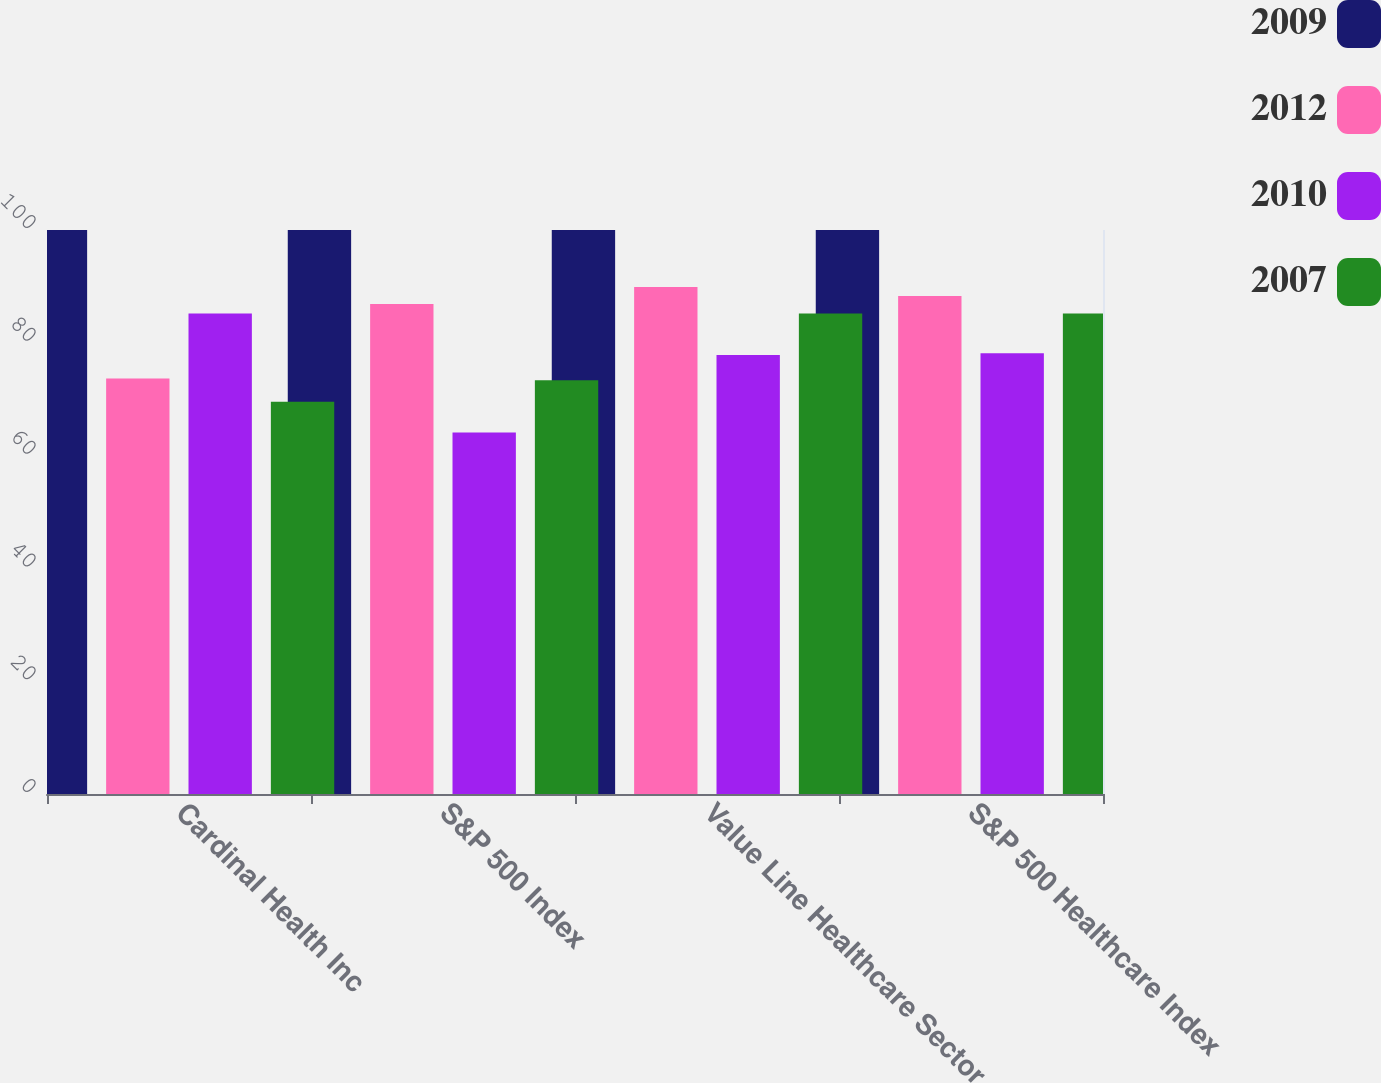Convert chart to OTSL. <chart><loc_0><loc_0><loc_500><loc_500><stacked_bar_chart><ecel><fcel>Cardinal Health Inc<fcel>S&P 500 Index<fcel>Value Line Healthcare Sector<fcel>S&P 500 Healthcare Index<nl><fcel>2009<fcel>100<fcel>100<fcel>100<fcel>100<nl><fcel>2012<fcel>73.68<fcel>86.88<fcel>89.88<fcel>88.28<nl><fcel>2010<fcel>85.2<fcel>64.11<fcel>77.82<fcel>78.15<nl><fcel>2007<fcel>69.56<fcel>73.36<fcel>85.2<fcel>85.18<nl></chart> 